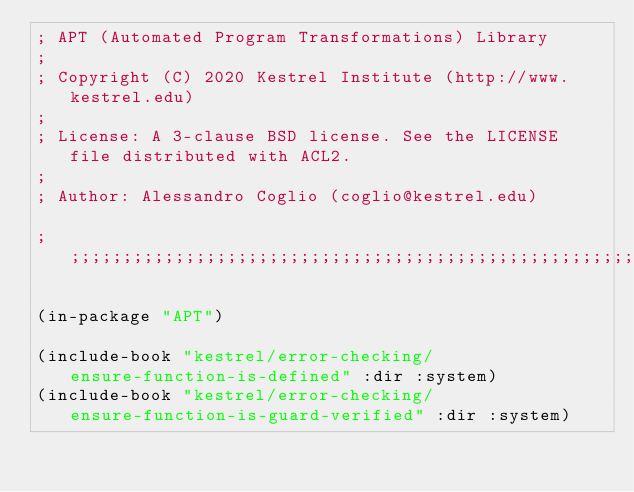<code> <loc_0><loc_0><loc_500><loc_500><_Lisp_>; APT (Automated Program Transformations) Library
;
; Copyright (C) 2020 Kestrel Institute (http://www.kestrel.edu)
;
; License: A 3-clause BSD license. See the LICENSE file distributed with ACL2.
;
; Author: Alessandro Coglio (coglio@kestrel.edu)

;;;;;;;;;;;;;;;;;;;;;;;;;;;;;;;;;;;;;;;;;;;;;;;;;;;;;;;;;;;;;;;;;;;;;;;;;;;;;;;;

(in-package "APT")

(include-book "kestrel/error-checking/ensure-function-is-defined" :dir :system)
(include-book "kestrel/error-checking/ensure-function-is-guard-verified" :dir :system)</code> 